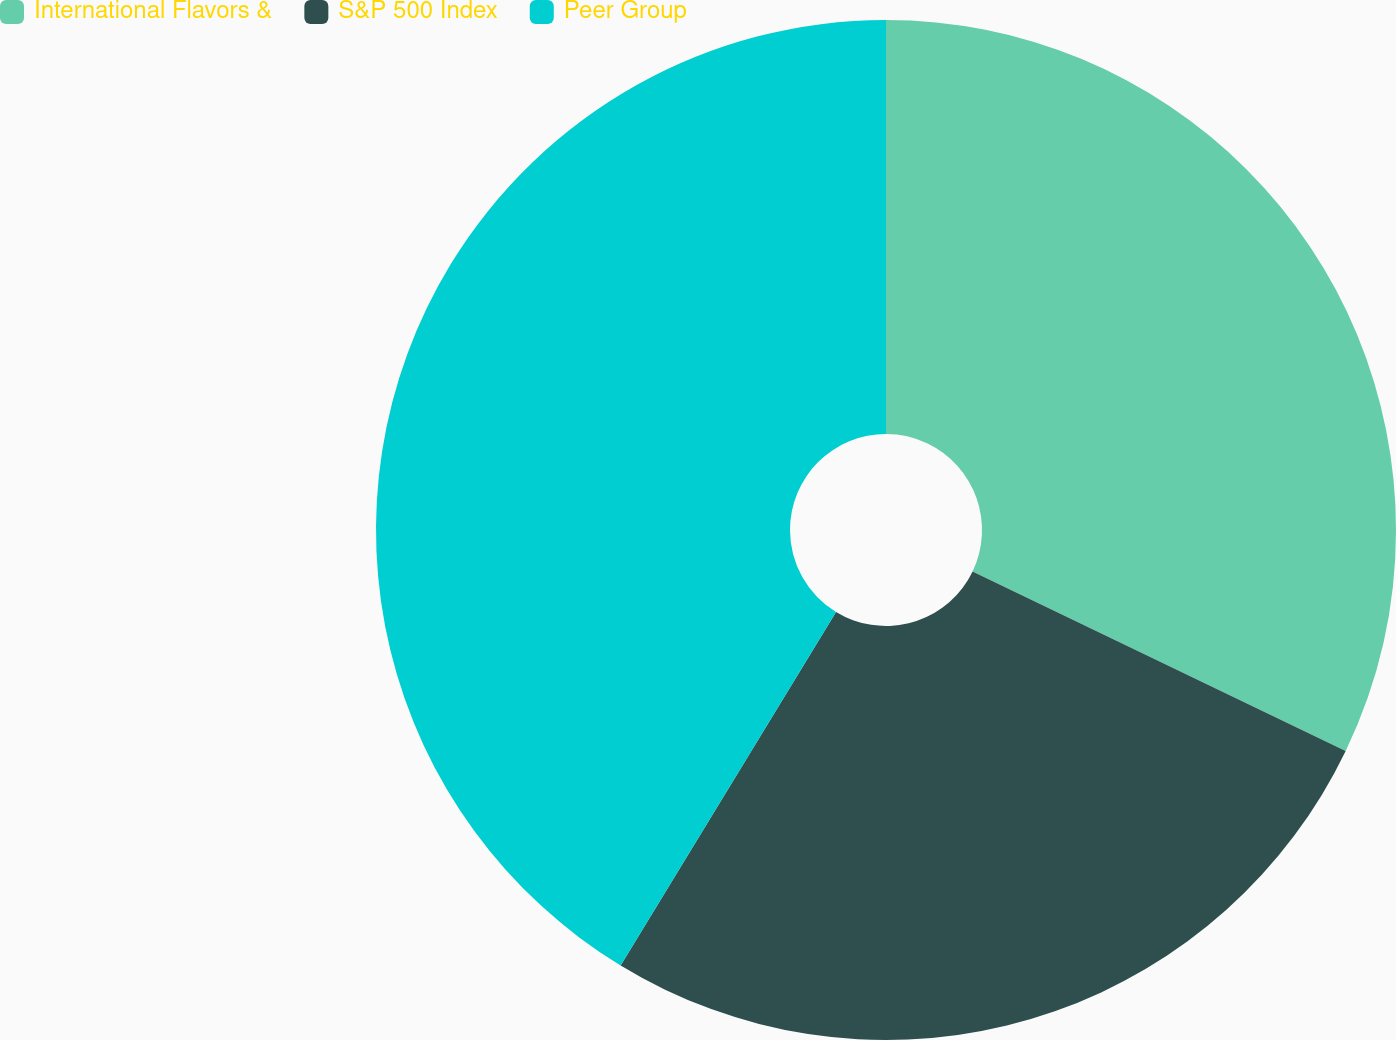Convert chart. <chart><loc_0><loc_0><loc_500><loc_500><pie_chart><fcel>International Flavors &<fcel>S&P 500 Index<fcel>Peer Group<nl><fcel>32.13%<fcel>26.58%<fcel>41.29%<nl></chart> 